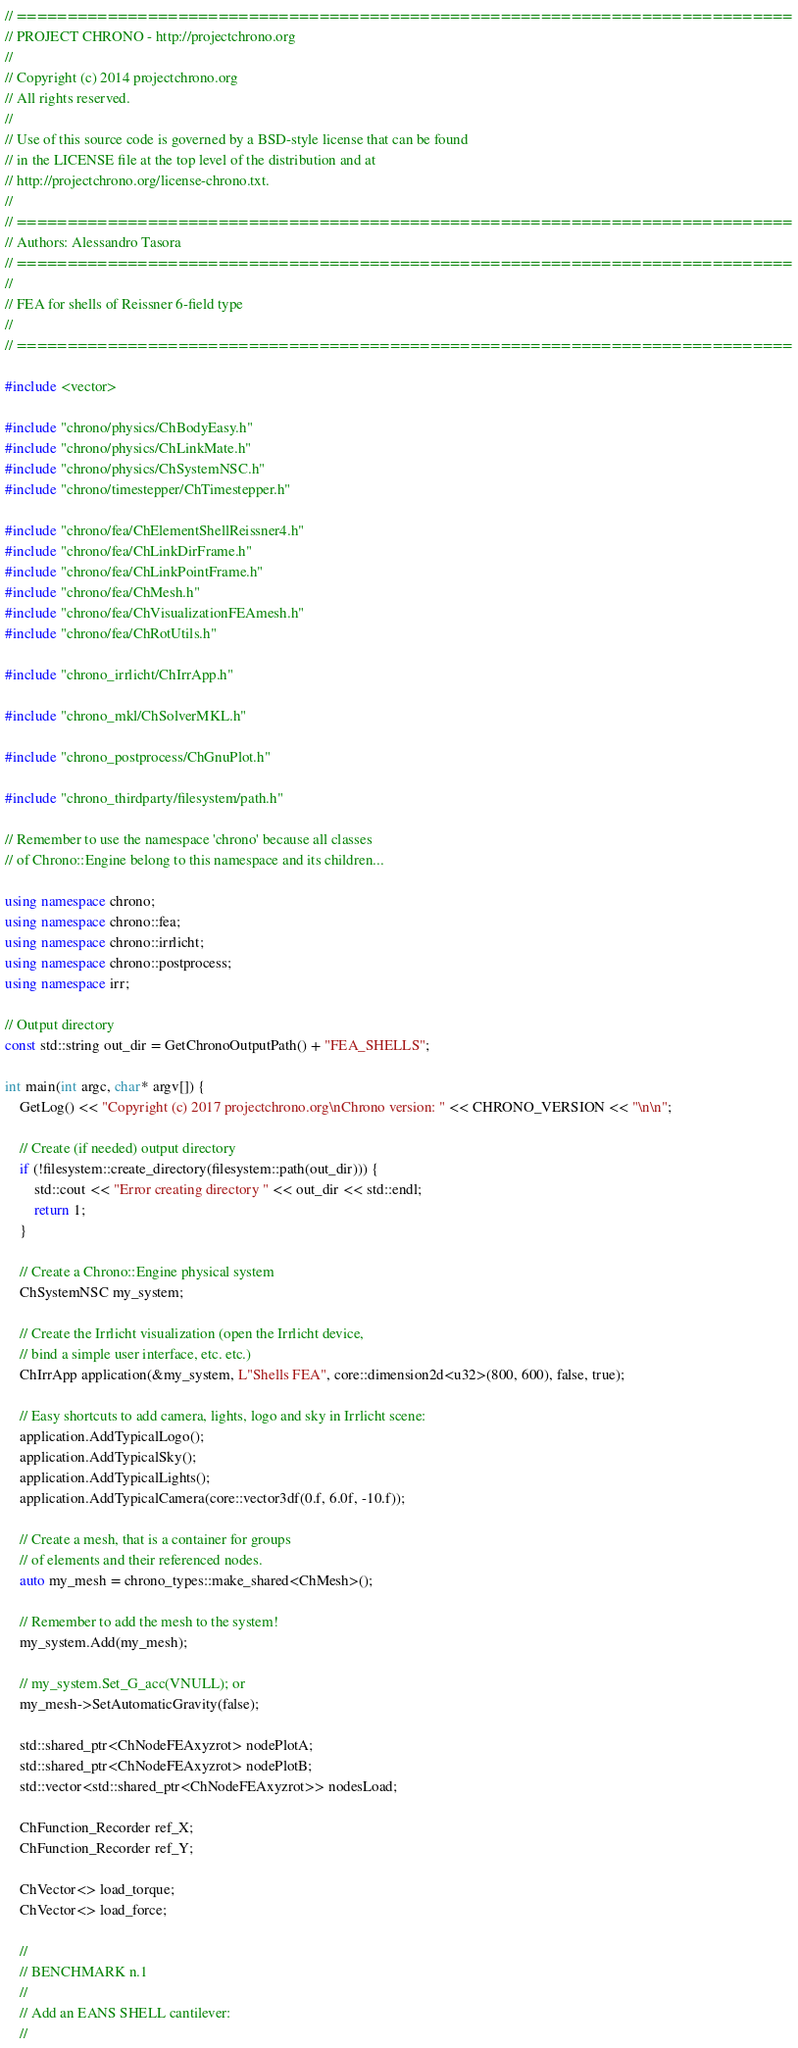<code> <loc_0><loc_0><loc_500><loc_500><_C++_>// =============================================================================
// PROJECT CHRONO - http://projectchrono.org
//
// Copyright (c) 2014 projectchrono.org
// All rights reserved.
//
// Use of this source code is governed by a BSD-style license that can be found
// in the LICENSE file at the top level of the distribution and at
// http://projectchrono.org/license-chrono.txt.
//
// =============================================================================
// Authors: Alessandro Tasora
// =============================================================================
//
// FEA for shells of Reissner 6-field type
//
// =============================================================================

#include <vector>

#include "chrono/physics/ChBodyEasy.h"
#include "chrono/physics/ChLinkMate.h"
#include "chrono/physics/ChSystemNSC.h"
#include "chrono/timestepper/ChTimestepper.h"

#include "chrono/fea/ChElementShellReissner4.h"
#include "chrono/fea/ChLinkDirFrame.h"
#include "chrono/fea/ChLinkPointFrame.h"
#include "chrono/fea/ChMesh.h"
#include "chrono/fea/ChVisualizationFEAmesh.h"
#include "chrono/fea/ChRotUtils.h"

#include "chrono_irrlicht/ChIrrApp.h"

#include "chrono_mkl/ChSolverMKL.h"

#include "chrono_postprocess/ChGnuPlot.h"

#include "chrono_thirdparty/filesystem/path.h"

// Remember to use the namespace 'chrono' because all classes
// of Chrono::Engine belong to this namespace and its children...

using namespace chrono;
using namespace chrono::fea;
using namespace chrono::irrlicht;
using namespace chrono::postprocess;
using namespace irr;

// Output directory
const std::string out_dir = GetChronoOutputPath() + "FEA_SHELLS";

int main(int argc, char* argv[]) {
    GetLog() << "Copyright (c) 2017 projectchrono.org\nChrono version: " << CHRONO_VERSION << "\n\n";

    // Create (if needed) output directory
    if (!filesystem::create_directory(filesystem::path(out_dir))) {
        std::cout << "Error creating directory " << out_dir << std::endl;
        return 1;
    }

    // Create a Chrono::Engine physical system
    ChSystemNSC my_system;

    // Create the Irrlicht visualization (open the Irrlicht device,
    // bind a simple user interface, etc. etc.)
    ChIrrApp application(&my_system, L"Shells FEA", core::dimension2d<u32>(800, 600), false, true);

    // Easy shortcuts to add camera, lights, logo and sky in Irrlicht scene:
    application.AddTypicalLogo();
    application.AddTypicalSky();
    application.AddTypicalLights();
    application.AddTypicalCamera(core::vector3df(0.f, 6.0f, -10.f));

    // Create a mesh, that is a container for groups
    // of elements and their referenced nodes.
    auto my_mesh = chrono_types::make_shared<ChMesh>();

    // Remember to add the mesh to the system!
    my_system.Add(my_mesh);

    // my_system.Set_G_acc(VNULL); or
    my_mesh->SetAutomaticGravity(false);

    std::shared_ptr<ChNodeFEAxyzrot> nodePlotA;
    std::shared_ptr<ChNodeFEAxyzrot> nodePlotB;
    std::vector<std::shared_ptr<ChNodeFEAxyzrot>> nodesLoad;

    ChFunction_Recorder ref_X;
    ChFunction_Recorder ref_Y;

    ChVector<> load_torque;
    ChVector<> load_force;

    //
    // BENCHMARK n.1
    //
    // Add an EANS SHELL cantilever:
    //
</code> 